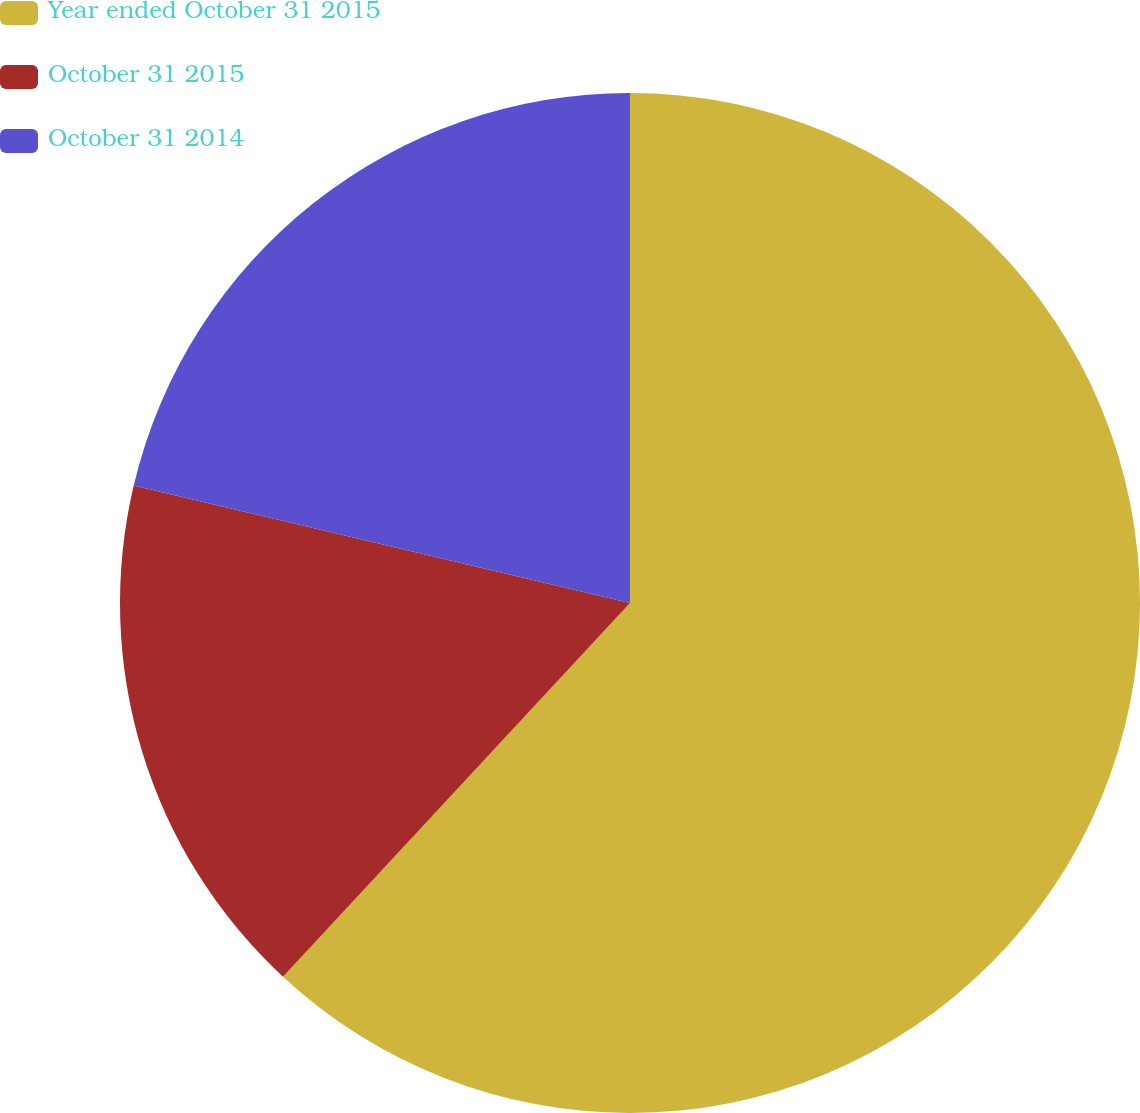Convert chart to OTSL. <chart><loc_0><loc_0><loc_500><loc_500><pie_chart><fcel>Year ended October 31 2015<fcel>October 31 2015<fcel>October 31 2014<nl><fcel>61.91%<fcel>16.79%<fcel>21.3%<nl></chart> 